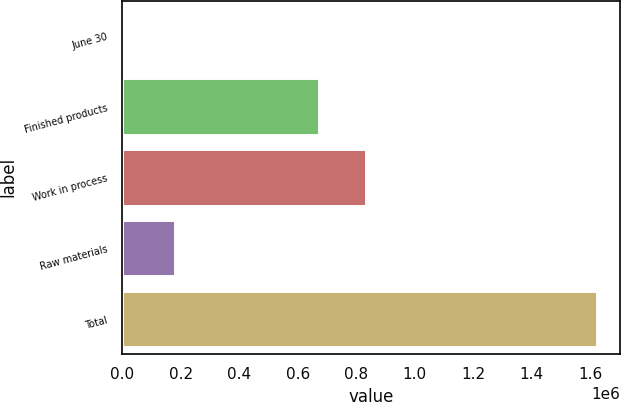Convert chart. <chart><loc_0><loc_0><loc_500><loc_500><bar_chart><fcel>June 30<fcel>Finished products<fcel>Work in process<fcel>Raw materials<fcel>Total<nl><fcel>2018<fcel>673323<fcel>835252<fcel>182146<fcel>1.6213e+06<nl></chart> 